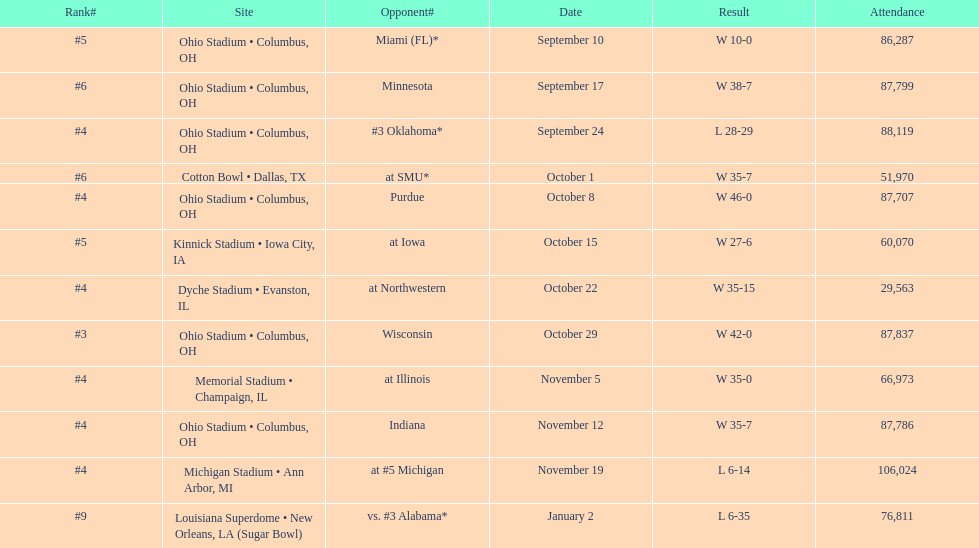How many games did this team win during this season? 9. 